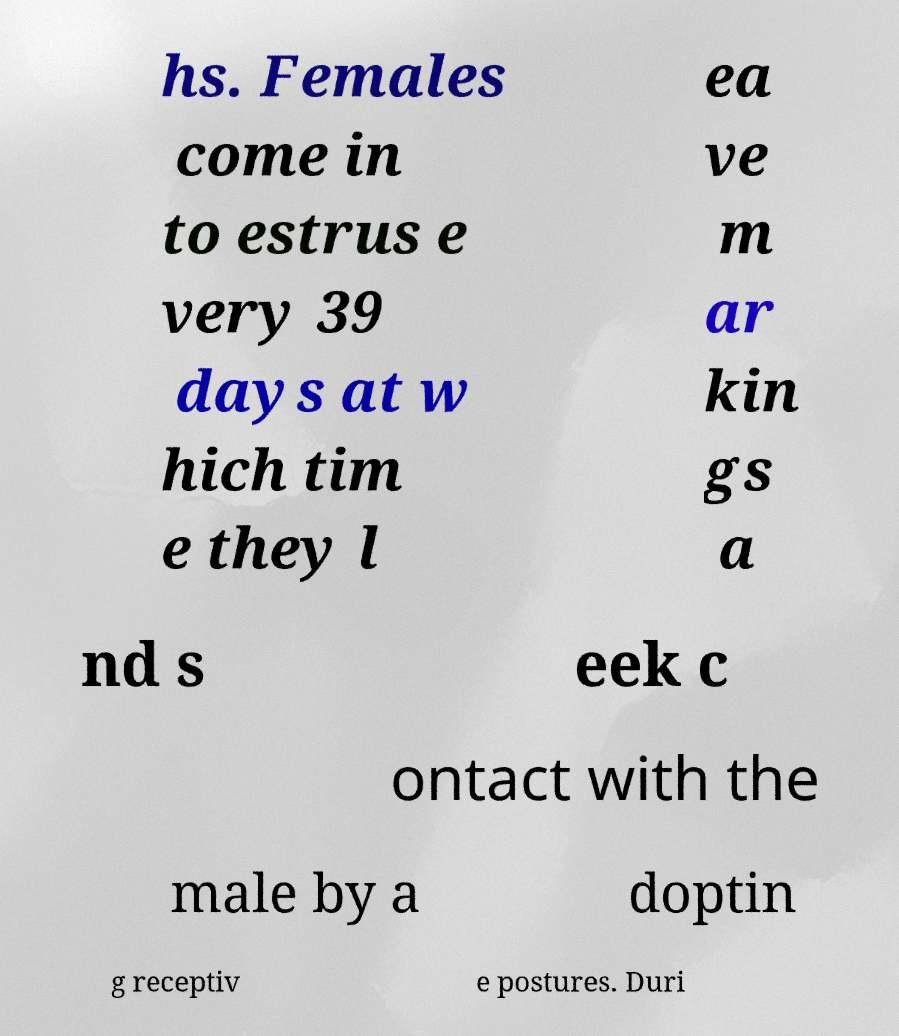There's text embedded in this image that I need extracted. Can you transcribe it verbatim? hs. Females come in to estrus e very 39 days at w hich tim e they l ea ve m ar kin gs a nd s eek c ontact with the male by a doptin g receptiv e postures. Duri 